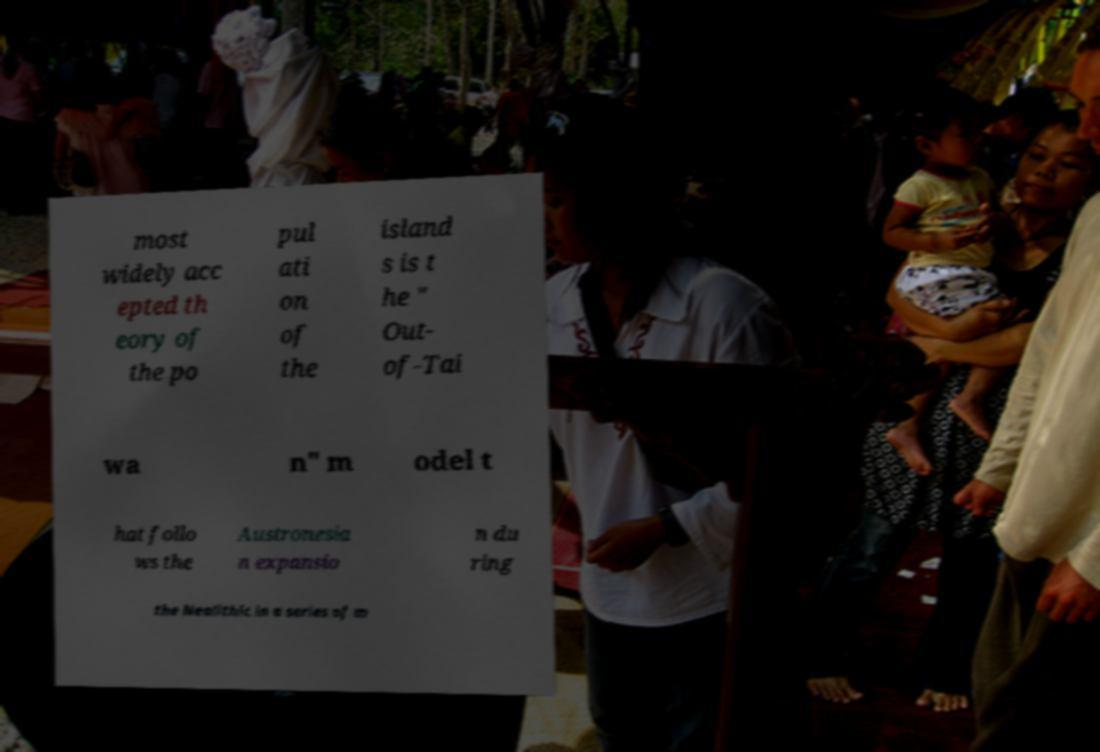For documentation purposes, I need the text within this image transcribed. Could you provide that? most widely acc epted th eory of the po pul ati on of the island s is t he " Out- of-Tai wa n" m odel t hat follo ws the Austronesia n expansio n du ring the Neolithic in a series of m 